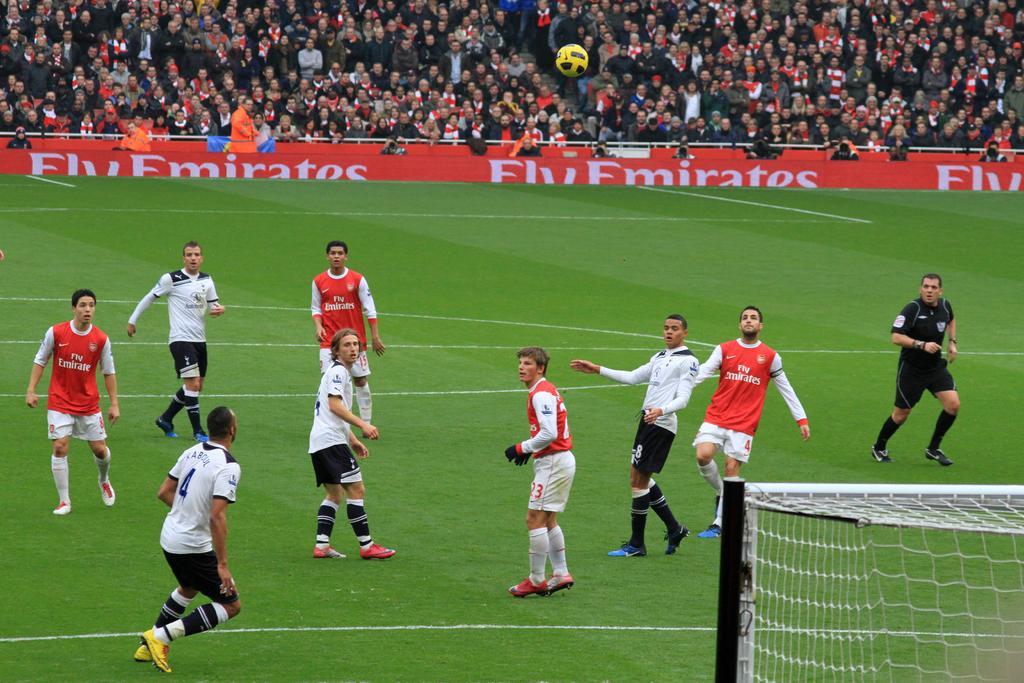Describe this image in one or two sentences. At the bottom right corner of the image there is a net. And in the middle of the image on the ground there are few people with red and white dress is running on the ground and also there is a man with black dress is also running. Behind them there is a red poster. Behind the poster there is a crowd. 